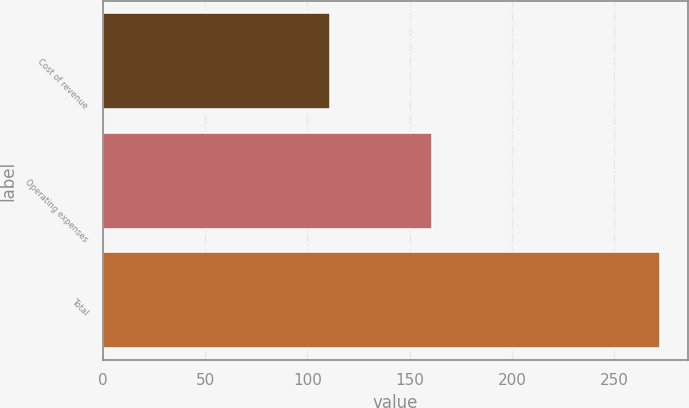<chart> <loc_0><loc_0><loc_500><loc_500><bar_chart><fcel>Cost of revenue<fcel>Operating expenses<fcel>Total<nl><fcel>111.2<fcel>160.9<fcel>272.1<nl></chart> 